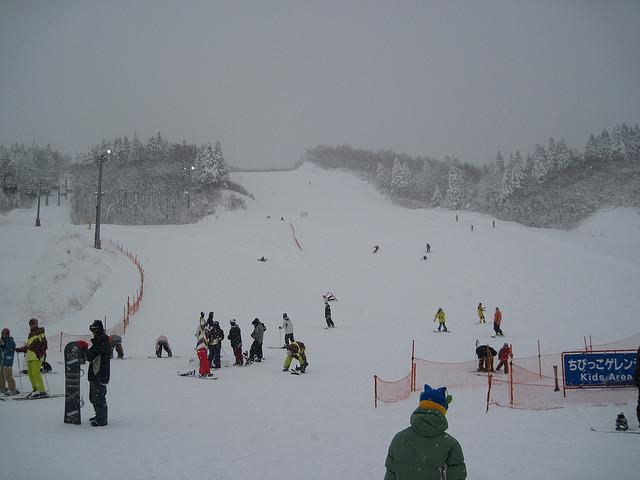Why is this hill so small? bunny hill 